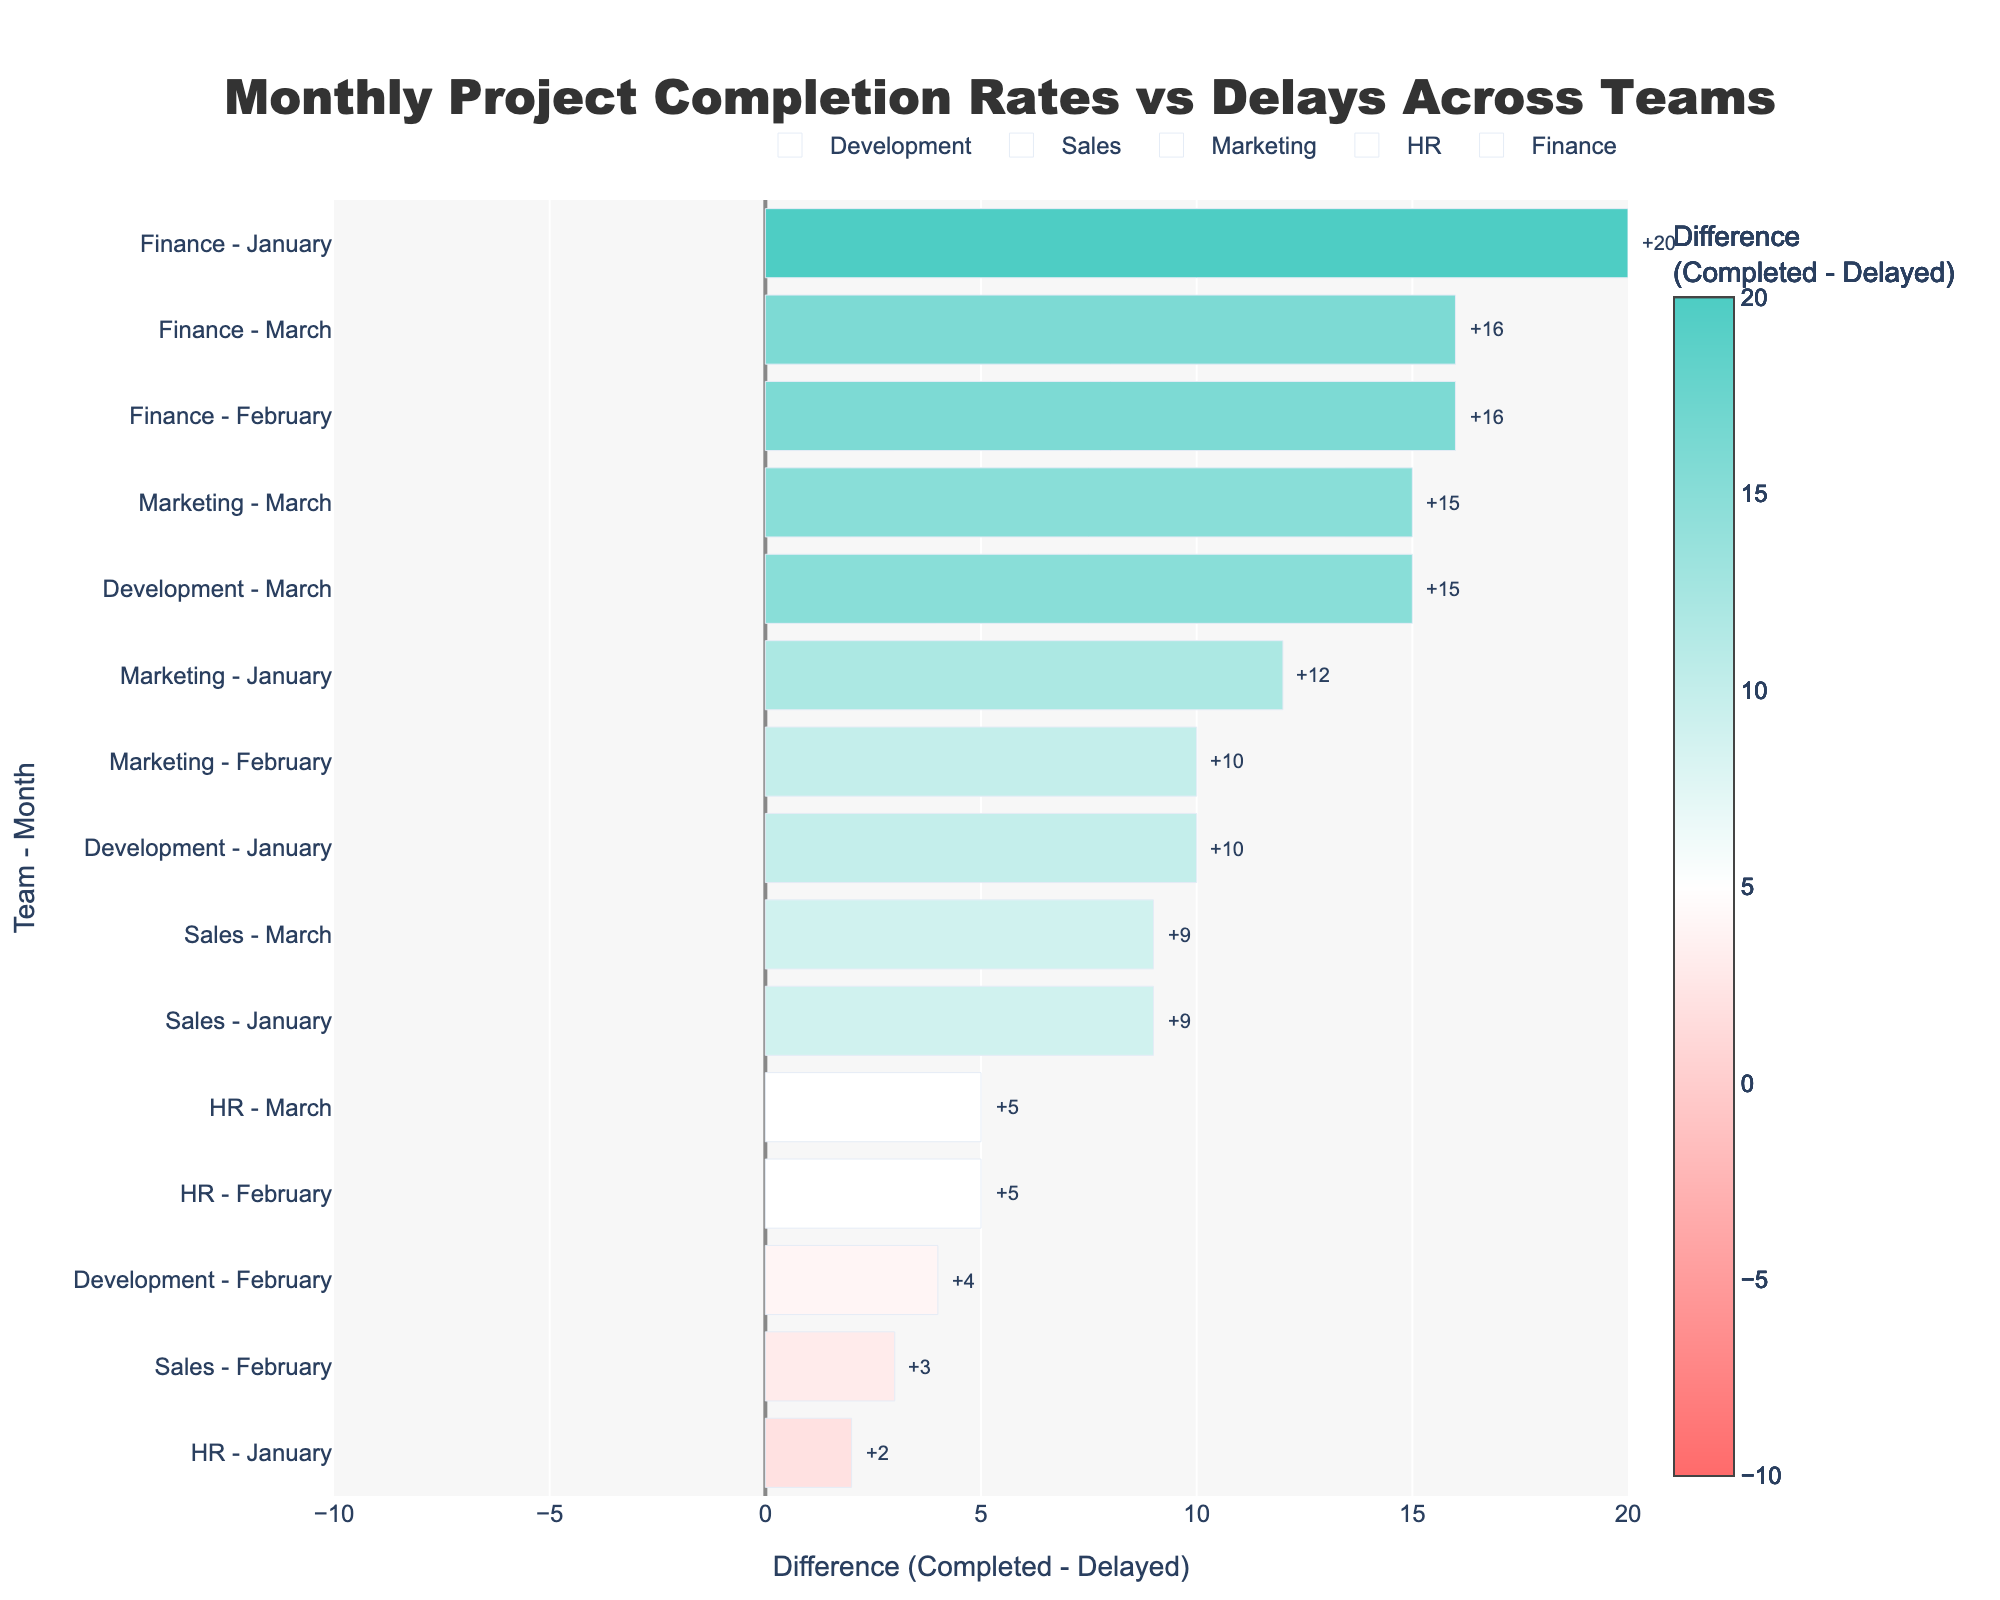Which team had the highest difference between completed and delayed projects in January? In January, we compare the difference values of each team: Development (10), Sales (9), Marketing (12), HR (2), and Finance (20). The highest is Finance with a difference of 20.
Answer: Finance Which month did the Development team see the largest decrease in the difference between completed and delayed projects? For Development, subtract their differences for each month: January (10 - February (-4)) = 14, and February (-4 - March (15)) = 19. The largest decrease is February, with a change of 14.
Answer: February Comparing the Marketing team in January and March, which month showed a greater positive difference? Marketing's difference in January is 12 and is 15 in March. Therefore, March has the greater positive difference.
Answer: March What is the average difference for the HR team across all months? HR's differences: January (2), February (5), and March (5). The sum is 2 + 5 + 5 = 12. The average is 12/3 = 4.
Answer: 4 Which team consistently had positive differences across all months? Checking differences: Development (10, 4, 15), Sales (9, 3, 9), Marketing (12, 10, 15), HR (2, 5, 5), Finance (20, 16, 16). All teams except for HR have shown positive differences in every month.
Answer: All except HR For February, which team had the lowest difference? The February differences: Development (-4), Sales (3), Marketing (10), HR (5), Finance (16). The lowest is Development with -4.
Answer: Development Did any team have a negative difference in any month? Checking each team's difference per month, only Development in February has a negative difference of -4.
Answer: Development What is the sum of differences for the Sales team across all months? The sum of Sales’ differences: January (9), February (3), and March (9). The total is 9 + 3 + 9 = 21.
Answer: 21 How many projects were completed by the Finance team in the month with its lowest difference? Finance has lowest difference in February (16). In February, Finance completed 18 projects.
Answer: 18 